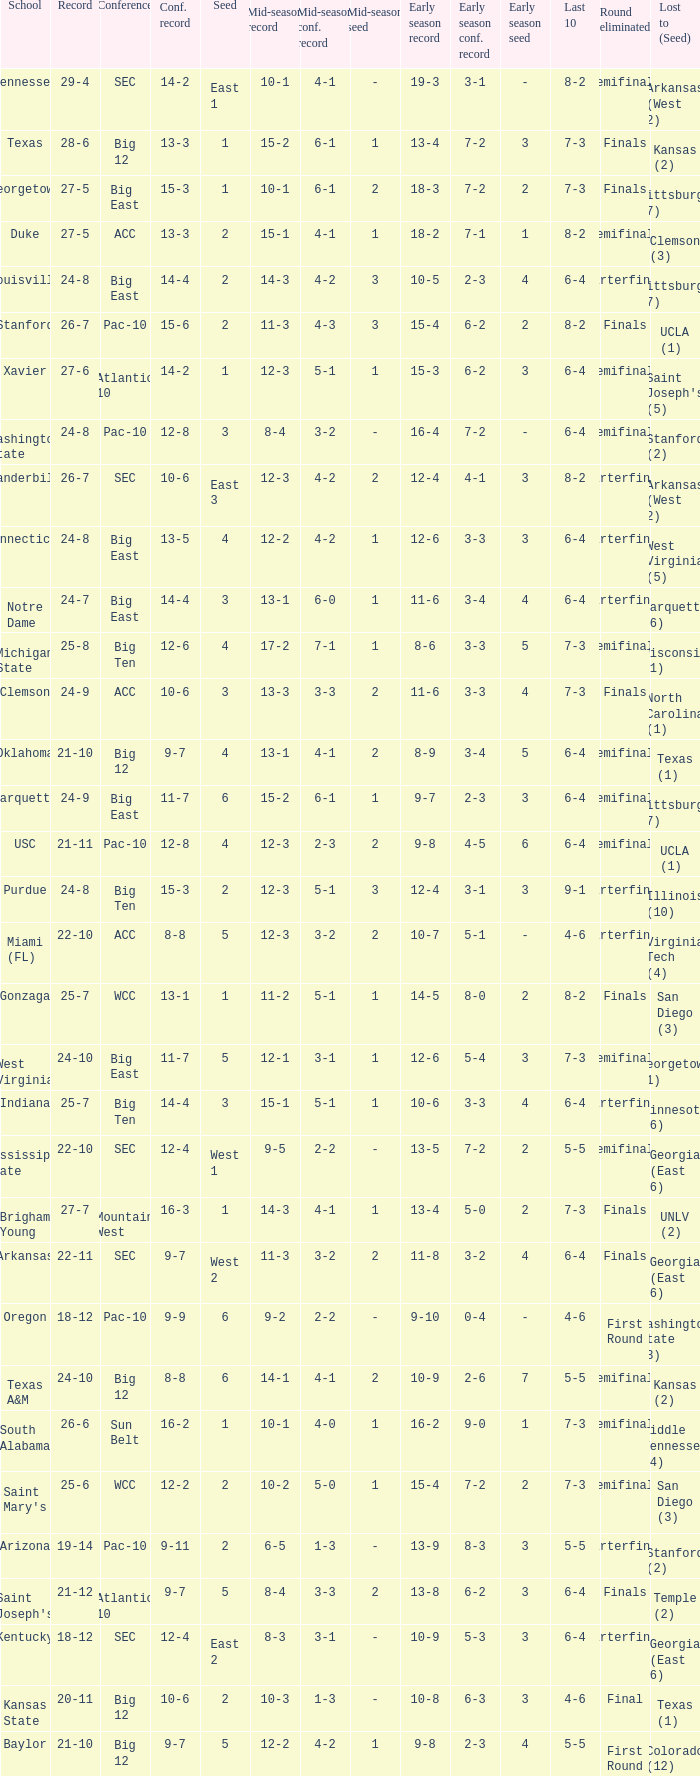Name the conference record where seed is 3 and record is 24-9 10-6. 